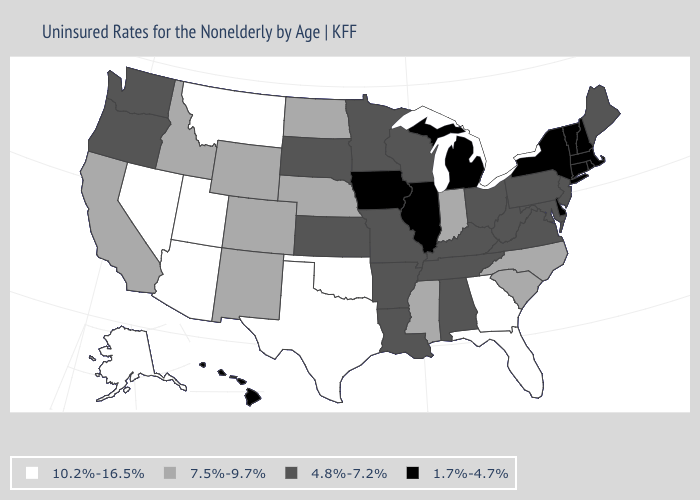What is the value of Maryland?
Short answer required. 4.8%-7.2%. Name the states that have a value in the range 10.2%-16.5%?
Answer briefly. Alaska, Arizona, Florida, Georgia, Montana, Nevada, Oklahoma, Texas, Utah. Among the states that border Maine , which have the highest value?
Quick response, please. New Hampshire. What is the highest value in the USA?
Short answer required. 10.2%-16.5%. Name the states that have a value in the range 1.7%-4.7%?
Concise answer only. Connecticut, Delaware, Hawaii, Illinois, Iowa, Massachusetts, Michigan, New Hampshire, New York, Rhode Island, Vermont. Name the states that have a value in the range 7.5%-9.7%?
Give a very brief answer. California, Colorado, Idaho, Indiana, Mississippi, Nebraska, New Mexico, North Carolina, North Dakota, South Carolina, Wyoming. Does Iowa have a lower value than Hawaii?
Quick response, please. No. Does New Jersey have the lowest value in the USA?
Write a very short answer. No. What is the value of Virginia?
Quick response, please. 4.8%-7.2%. What is the value of Mississippi?
Write a very short answer. 7.5%-9.7%. What is the highest value in states that border New Hampshire?
Answer briefly. 4.8%-7.2%. What is the value of Connecticut?
Concise answer only. 1.7%-4.7%. What is the highest value in states that border Illinois?
Give a very brief answer. 7.5%-9.7%. What is the value of Washington?
Give a very brief answer. 4.8%-7.2%. Name the states that have a value in the range 7.5%-9.7%?
Short answer required. California, Colorado, Idaho, Indiana, Mississippi, Nebraska, New Mexico, North Carolina, North Dakota, South Carolina, Wyoming. 